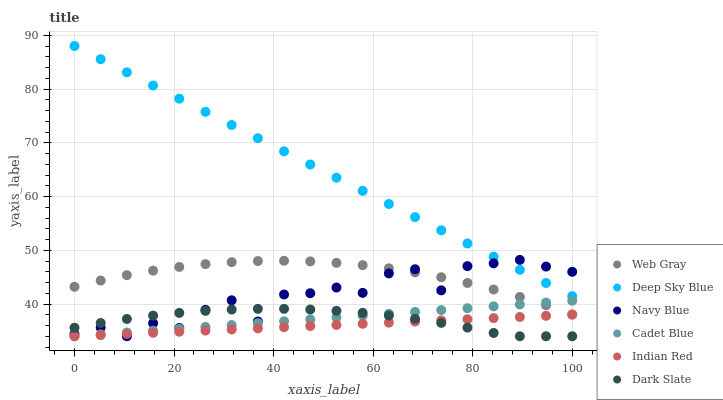Does Indian Red have the minimum area under the curve?
Answer yes or no. Yes. Does Deep Sky Blue have the maximum area under the curve?
Answer yes or no. Yes. Does Navy Blue have the minimum area under the curve?
Answer yes or no. No. Does Navy Blue have the maximum area under the curve?
Answer yes or no. No. Is Cadet Blue the smoothest?
Answer yes or no. Yes. Is Navy Blue the roughest?
Answer yes or no. Yes. Is Deep Sky Blue the smoothest?
Answer yes or no. No. Is Deep Sky Blue the roughest?
Answer yes or no. No. Does Cadet Blue have the lowest value?
Answer yes or no. Yes. Does Deep Sky Blue have the lowest value?
Answer yes or no. No. Does Deep Sky Blue have the highest value?
Answer yes or no. Yes. Does Navy Blue have the highest value?
Answer yes or no. No. Is Web Gray less than Deep Sky Blue?
Answer yes or no. Yes. Is Web Gray greater than Indian Red?
Answer yes or no. Yes. Does Navy Blue intersect Web Gray?
Answer yes or no. Yes. Is Navy Blue less than Web Gray?
Answer yes or no. No. Is Navy Blue greater than Web Gray?
Answer yes or no. No. Does Web Gray intersect Deep Sky Blue?
Answer yes or no. No. 